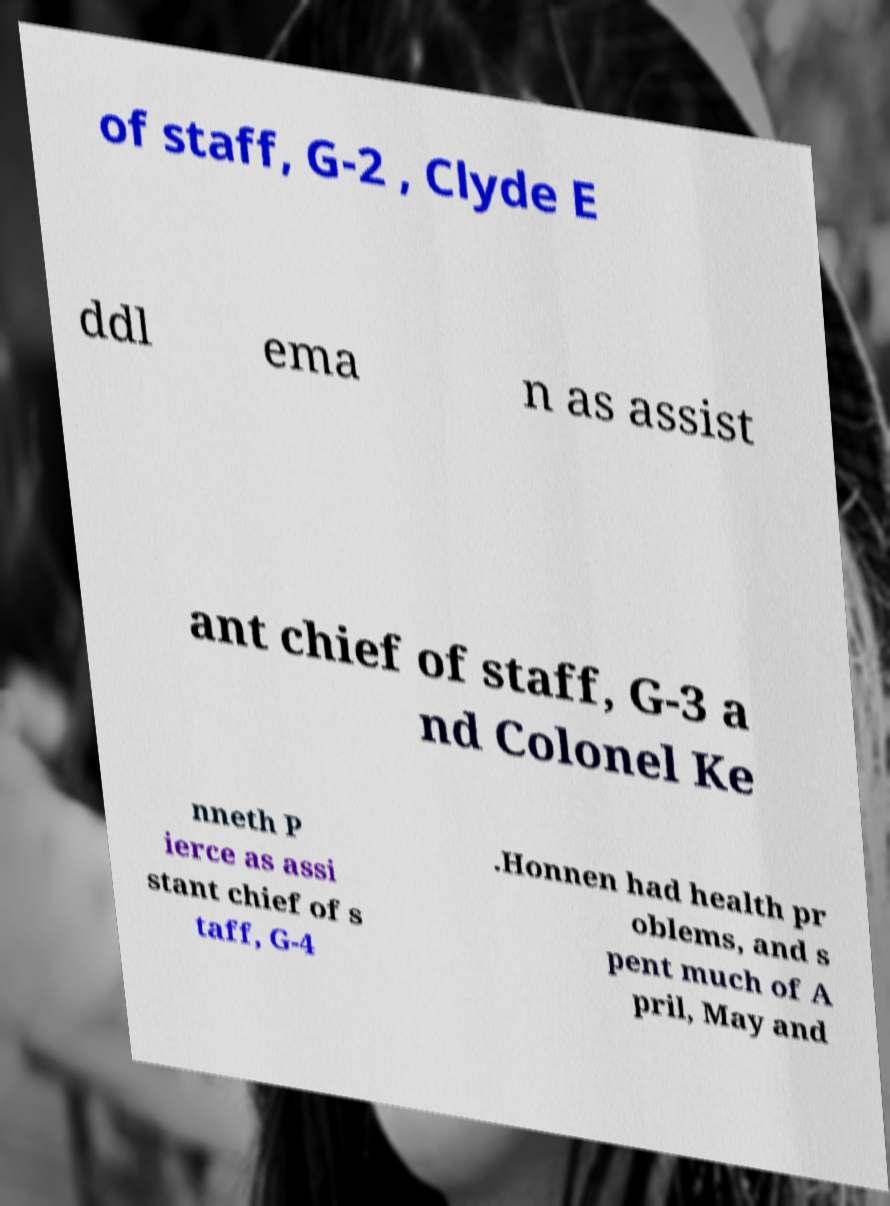Can you read and provide the text displayed in the image?This photo seems to have some interesting text. Can you extract and type it out for me? of staff, G-2 , Clyde E ddl ema n as assist ant chief of staff, G-3 a nd Colonel Ke nneth P ierce as assi stant chief of s taff, G-4 .Honnen had health pr oblems, and s pent much of A pril, May and 